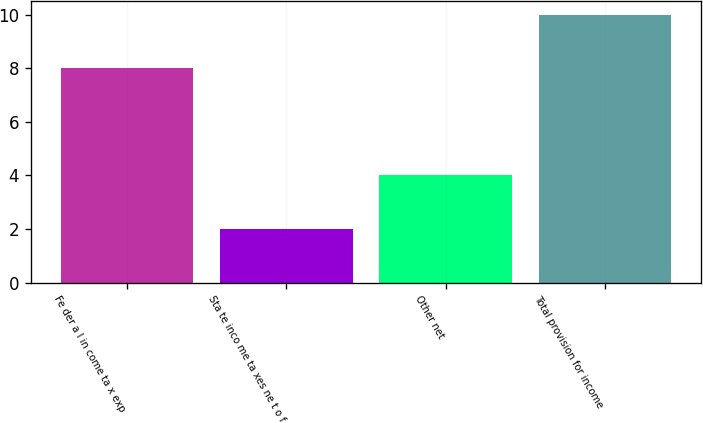Convert chart. <chart><loc_0><loc_0><loc_500><loc_500><bar_chart><fcel>Fe der a l in come ta x exp<fcel>Sta te inco me ta xes ne t o f<fcel>Other net<fcel>Total provision for income<nl><fcel>8<fcel>2<fcel>4<fcel>10<nl></chart> 